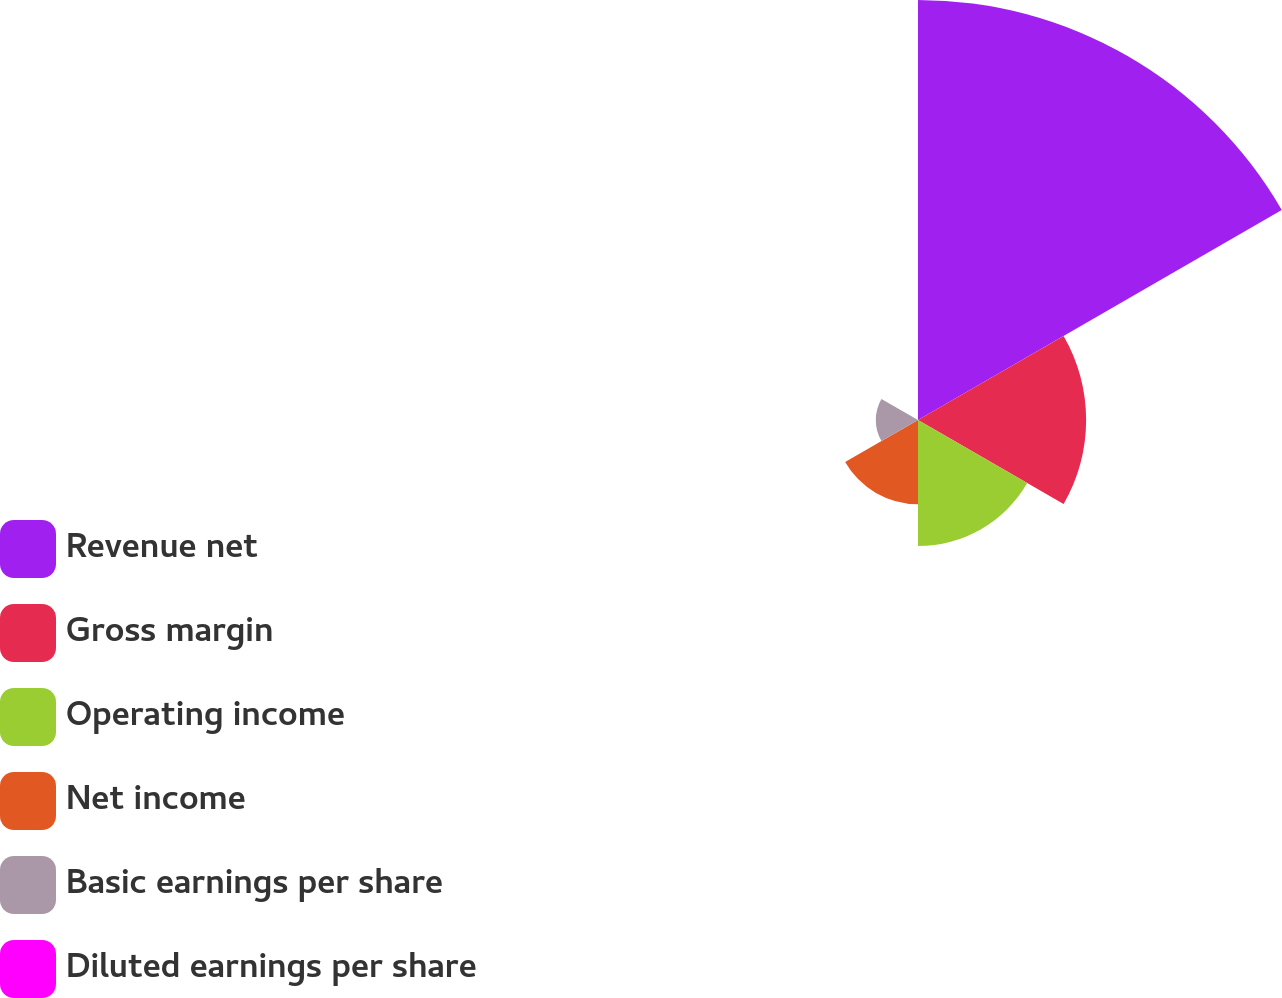Convert chart to OTSL. <chart><loc_0><loc_0><loc_500><loc_500><pie_chart><fcel>Revenue net<fcel>Gross margin<fcel>Operating income<fcel>Net income<fcel>Basic earnings per share<fcel>Diluted earnings per share<nl><fcel>49.96%<fcel>20.0%<fcel>15.0%<fcel>10.01%<fcel>5.02%<fcel>0.02%<nl></chart> 